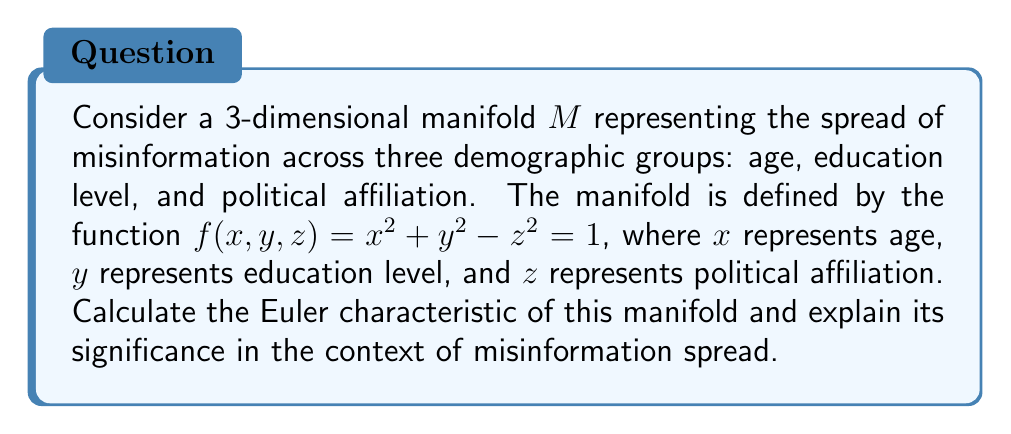What is the answer to this math problem? To solve this problem, we'll follow these steps:

1) Identify the manifold: The given equation $f(x, y, z) = x^2 + y^2 - z^2 = 1$ describes a hyperboloid of one sheet.

2) Calculate the Euler characteristic:
   The Euler characteristic of a hyperboloid of one sheet is 0.

3) Interpret the result:
   The Euler characteristic is a topological invariant that provides information about the shape and structure of a manifold. For a hyperboloid of one sheet, χ = 0 indicates that:

   a) The manifold is neither a sphere (χ = 2) nor a torus (χ = 0), but has a more complex topology.
   
   b) It has no boundary, is non-compact, and extends infinitely in all directions.
   
   c) It has a "saddle-like" shape at its center, indicating areas of both positive and negative curvature.

In the context of misinformation spread:

- The non-compact nature suggests that misinformation can potentially spread without bounds across these demographic dimensions.

- The saddle shape implies that there are regions where misinformation spread accelerates (positive curvature) and regions where it decelerates (negative curvature).

- The Euler characteristic of 0 indicates a balance between these acceleration and deceleration regions, suggesting a complex, non-uniform spread of misinformation across different demographic combinations.

- The absence of boundaries implies that no demographic group is completely immune to or isolated from misinformation.

This topological analysis provides insights into the complex dynamics of misinformation spread across different demographic groups, highlighting the need for nuanced strategies in combating fake news that account for these varying patterns of spread.
Answer: The Euler characteristic of the manifold is 0. 